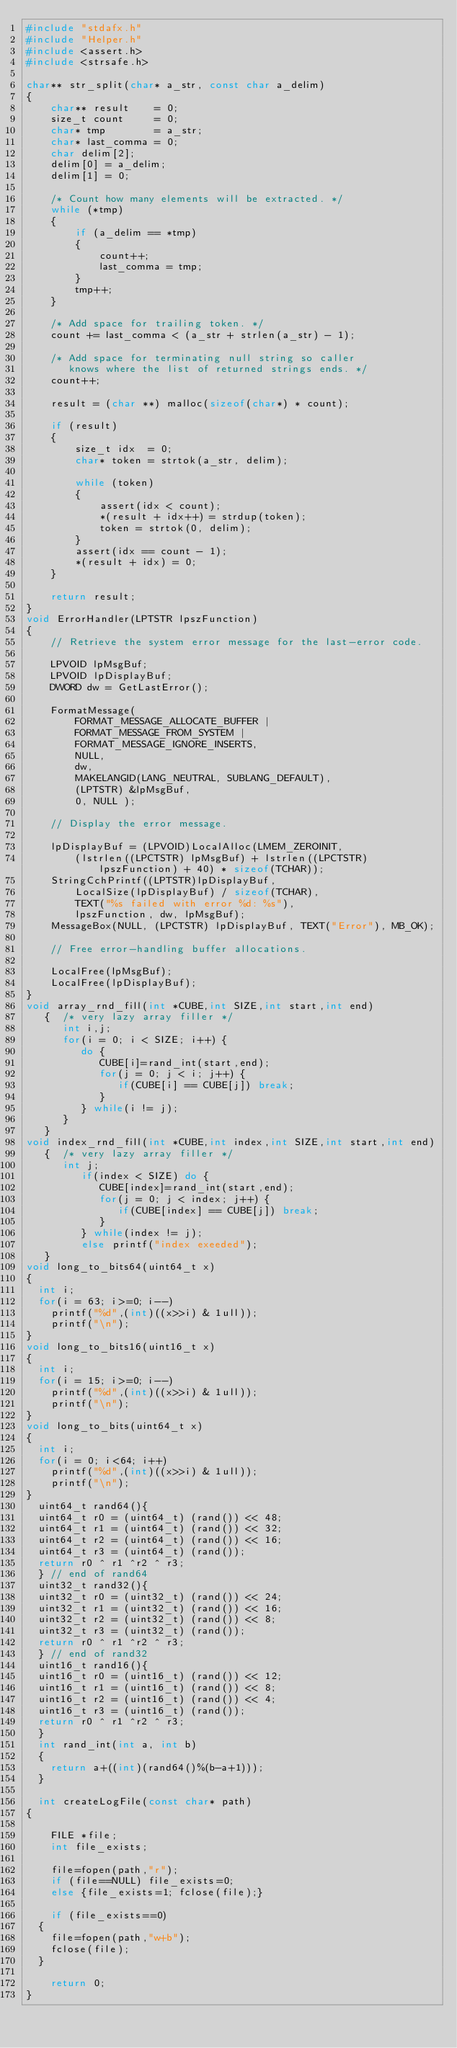<code> <loc_0><loc_0><loc_500><loc_500><_C++_>#include "stdafx.h"
#include "Helper.h"
#include <assert.h>
#include <strsafe.h>

char** str_split(char* a_str, const char a_delim)
{
    char** result    = 0;
    size_t count     = 0;
    char* tmp        = a_str;
    char* last_comma = 0;
    char delim[2];
    delim[0] = a_delim;
    delim[1] = 0;

    /* Count how many elements will be extracted. */
    while (*tmp)
    {
        if (a_delim == *tmp)
        {
            count++;
            last_comma = tmp;
        }
        tmp++;
    }

    /* Add space for trailing token. */
    count += last_comma < (a_str + strlen(a_str) - 1);

    /* Add space for terminating null string so caller
       knows where the list of returned strings ends. */
    count++;

    result = (char **) malloc(sizeof(char*) * count);

    if (result)
    {
        size_t idx  = 0;
        char* token = strtok(a_str, delim);

        while (token)
        {
            assert(idx < count);
            *(result + idx++) = strdup(token);
            token = strtok(0, delim);
        }
        assert(idx == count - 1);
        *(result + idx) = 0;
    }

    return result;
}
void ErrorHandler(LPTSTR lpszFunction) 
{ 
    // Retrieve the system error message for the last-error code.

    LPVOID lpMsgBuf;
    LPVOID lpDisplayBuf;
    DWORD dw = GetLastError(); 

    FormatMessage(
        FORMAT_MESSAGE_ALLOCATE_BUFFER | 
        FORMAT_MESSAGE_FROM_SYSTEM |
        FORMAT_MESSAGE_IGNORE_INSERTS,
        NULL,
        dw,
        MAKELANGID(LANG_NEUTRAL, SUBLANG_DEFAULT),
        (LPTSTR) &lpMsgBuf,
        0, NULL );

    // Display the error message.

    lpDisplayBuf = (LPVOID)LocalAlloc(LMEM_ZEROINIT, 
        (lstrlen((LPCTSTR) lpMsgBuf) + lstrlen((LPCTSTR) lpszFunction) + 40) * sizeof(TCHAR)); 
    StringCchPrintf((LPTSTR)lpDisplayBuf, 
        LocalSize(lpDisplayBuf) / sizeof(TCHAR),
        TEXT("%s failed with error %d: %s"), 
        lpszFunction, dw, lpMsgBuf); 
    MessageBox(NULL, (LPCTSTR) lpDisplayBuf, TEXT("Error"), MB_OK); 

    // Free error-handling buffer allocations.

    LocalFree(lpMsgBuf);
    LocalFree(lpDisplayBuf);
}
void array_rnd_fill(int *CUBE,int SIZE,int start,int end)
   {  /* very lazy array filler */
      int i,j;
      for(i = 0; i < SIZE; i++) {
         do {
            CUBE[i]=rand_int(start,end);
            for(j = 0; j < i; j++) {
               if(CUBE[i] == CUBE[j]) break;
            }
         } while(i != j);
      }
   }
void index_rnd_fill(int *CUBE,int index,int SIZE,int start,int end)
   {  /* very lazy array filler */
      int j;
         if(index < SIZE) do {
            CUBE[index]=rand_int(start,end);
            for(j = 0; j < index; j++) {
               if(CUBE[index] == CUBE[j]) break;
            }
         } while(index != j);
         else printf("index exeeded");
   }
void long_to_bits64(uint64_t x)
{
	int i;
	for(i = 63; i>=0; i--)
		printf("%d",(int)((x>>i) & 1ull));
		printf("\n");
}
void long_to_bits16(uint16_t x)
{
	int i;
	for(i = 15; i>=0; i--)
		printf("%d",(int)((x>>i) & 1ull));
		printf("\n");
}
void long_to_bits(uint64_t x)
{
	int i;
	for(i = 0; i<64; i++)
		printf("%d",(int)((x>>i) & 1ull));
		printf("\n");
}
  uint64_t rand64(){
  uint64_t r0 = (uint64_t) (rand()) << 48;
  uint64_t r1 = (uint64_t) (rand()) << 32;
  uint64_t r2 = (uint64_t) (rand()) << 16;
  uint64_t r3 = (uint64_t) (rand());
  return r0 ^ r1 ^r2 ^ r3;
  } // end of rand64
  uint32_t rand32(){
  uint32_t r0 = (uint32_t) (rand()) << 24;
  uint32_t r1 = (uint32_t) (rand()) << 16;
  uint32_t r2 = (uint32_t) (rand()) << 8;
  uint32_t r3 = (uint32_t) (rand());
  return r0 ^ r1 ^r2 ^ r3;
  } // end of rand32
  uint16_t rand16(){
  uint16_t r0 = (uint16_t) (rand()) << 12;
  uint16_t r1 = (uint16_t) (rand()) << 8;
  uint16_t r2 = (uint16_t) (rand()) << 4;
  uint16_t r3 = (uint16_t) (rand());
  return r0 ^ r1 ^r2 ^ r3;
  }
  int rand_int(int a, int b)
  {
	  return a+((int)(rand64()%(b-a+1)));
  }

  int createLogFile(const char* path)
{

    FILE *file;
    int file_exists;

    file=fopen(path,"r");
    if (file==NULL) file_exists=0;
    else {file_exists=1; fclose(file);}
    
    if (file_exists==0)
	{
		file=fopen(path,"w+b");
		fclose(file);
	}

    return 0;
}</code> 